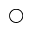<formula> <loc_0><loc_0><loc_500><loc_500>\bigcirc</formula> 